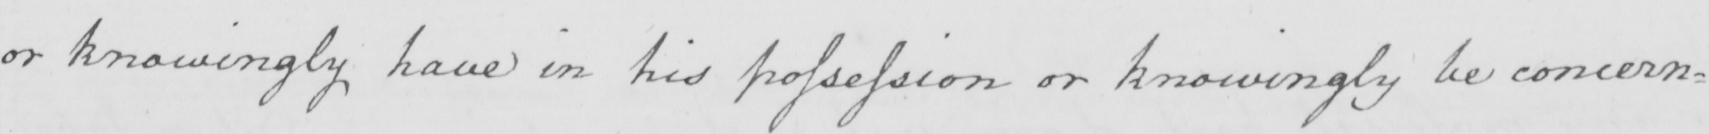Please transcribe the handwritten text in this image. or knowingly have in his possession or knowingly be concern= 